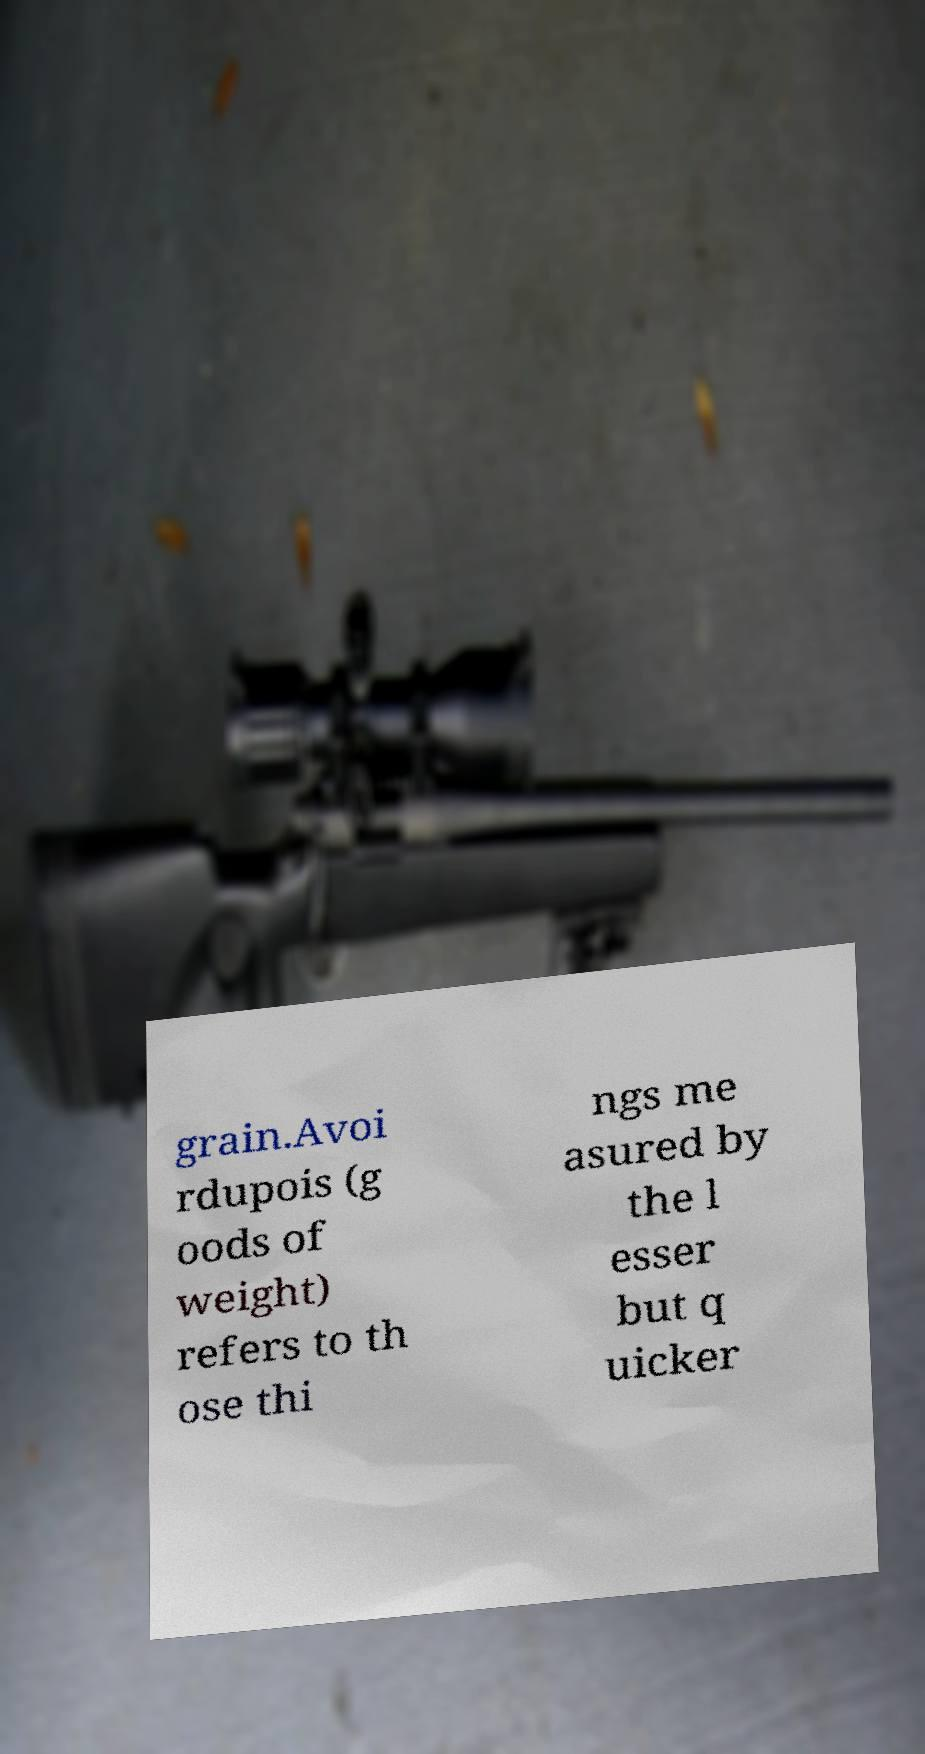Please identify and transcribe the text found in this image. grain.Avoi rdupois (g oods of weight) refers to th ose thi ngs me asured by the l esser but q uicker 